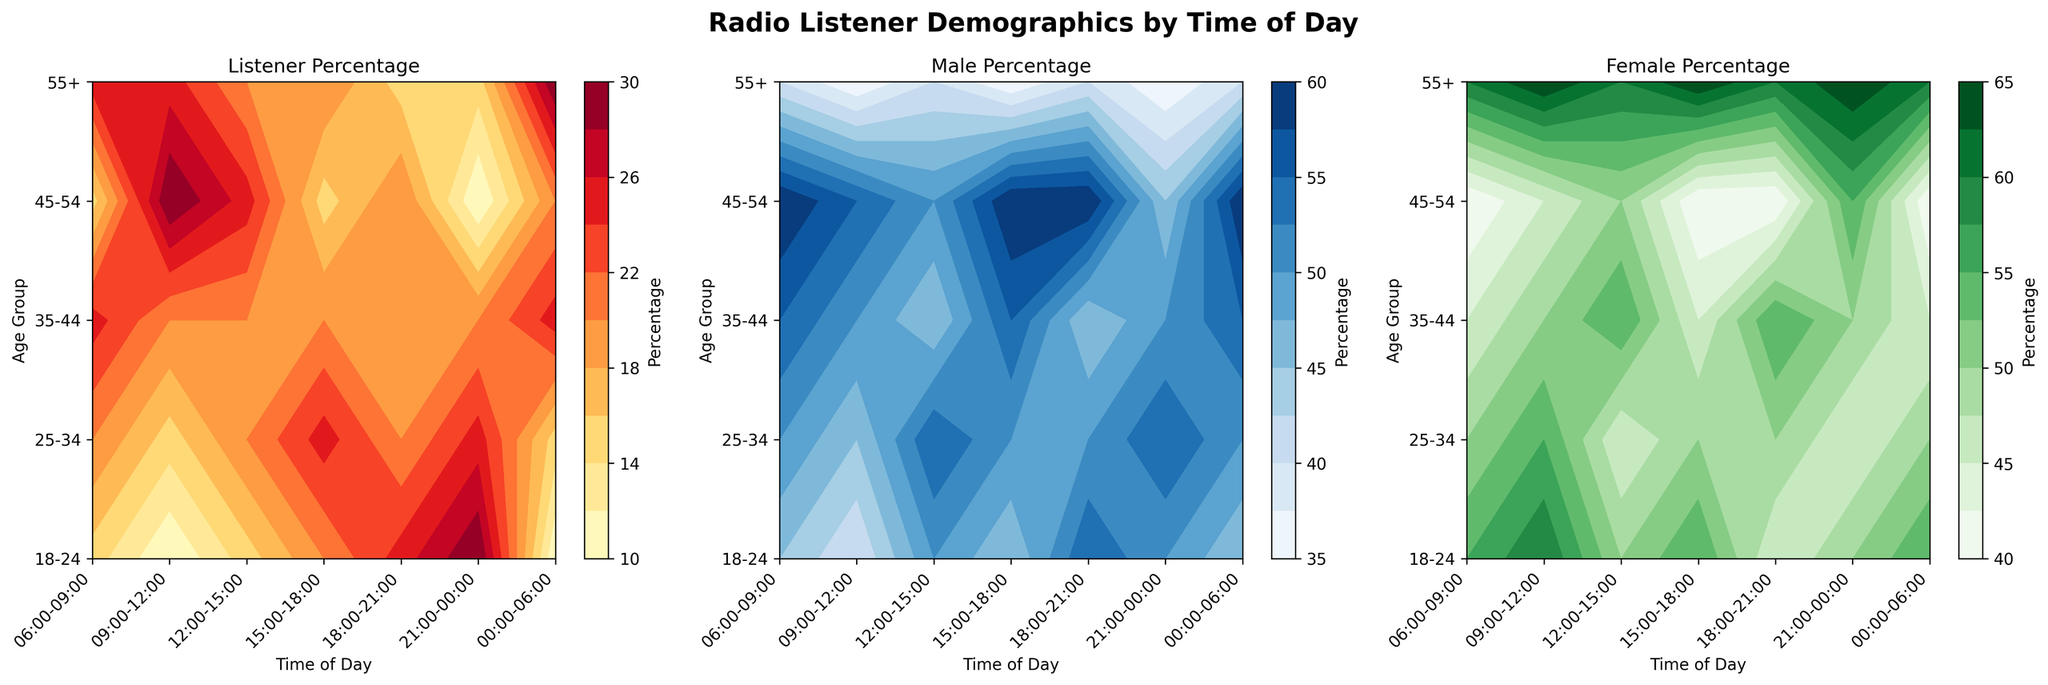Which age group has the highest listener percentage in the 06:00-09:00 time slot? Look at the Listener Percentage contour plot for the 06:00-09:00 time slot and identify the age group with the highest value.
Answer: 35-44 How does the male percentage for the 45-54 age group change from 06:00-09:00 to 09:00-12:00? Compare the male percentage in the Male Percentage contour plot for the 45-54 age group between the 06:00-09:00 and 09:00-12:00 time slots.
Answer: Decreases Which time slot has the highest female percentage for the 55+ age group? Look at the Female Percentage contour plot and find the time slot with the highest value for the 55+ age group.
Answer: 09:00-12:00 Among the 25-34 age group, is there a time slot where the listener percentage equals the listener percentage of the 55+ age group in the same slot? Check the Listener Percentage contour plot for the 25-34 age group and compare each time slot with the corresponding one in the 55+ age group.
Answer: Yes Which age group shows more balanced gender percentages throughout the day? Balance would imply closer values of male and female percentages. By checking both Male and Female Percentage contour plots, observe the age group that consistently has values close to 50% for both genders.
Answer: 25-34 Is there any time slot where the listener percentage is above 25% for all age groups? Look at the Listener Percentage contour plot to check if any time slot has a listener percentage above 25% for each age group.
Answer: No Which time slot and age group has the lowest listener percentage? Identify the lowest contour level on the Listener Percentage plot and note down its corresponding time slot and age group.
Answer: 00:00-06:00, 18-24 From 15:00-18:00, which percentage is higher for the 35-44 age group, male or female? Compare the male and female percentages within the 15:00-18:00 time slot for the 35-44 age group on the respective contour plots.
Answer: Male Between 18:00-21:00 and 21:00-00:00, which time slot has a higher overall listener percentage for the 18-24 age group? Look at the Listener Percentage contour plot for the 18-24 age group and compare the values between the 18:00-21:00 and 21:00-00:00 time slots.
Answer: 21:00-00:00 Which time slot has the most balanced listener percentages across all age groups? Balanced implies the gap between the highest and lowest percentages is minimal. Observe the Listener Percentage contour plot to find the time slot where the differences between age groups' listener percentages are the smallest.
Answer: 21:00-00:00 